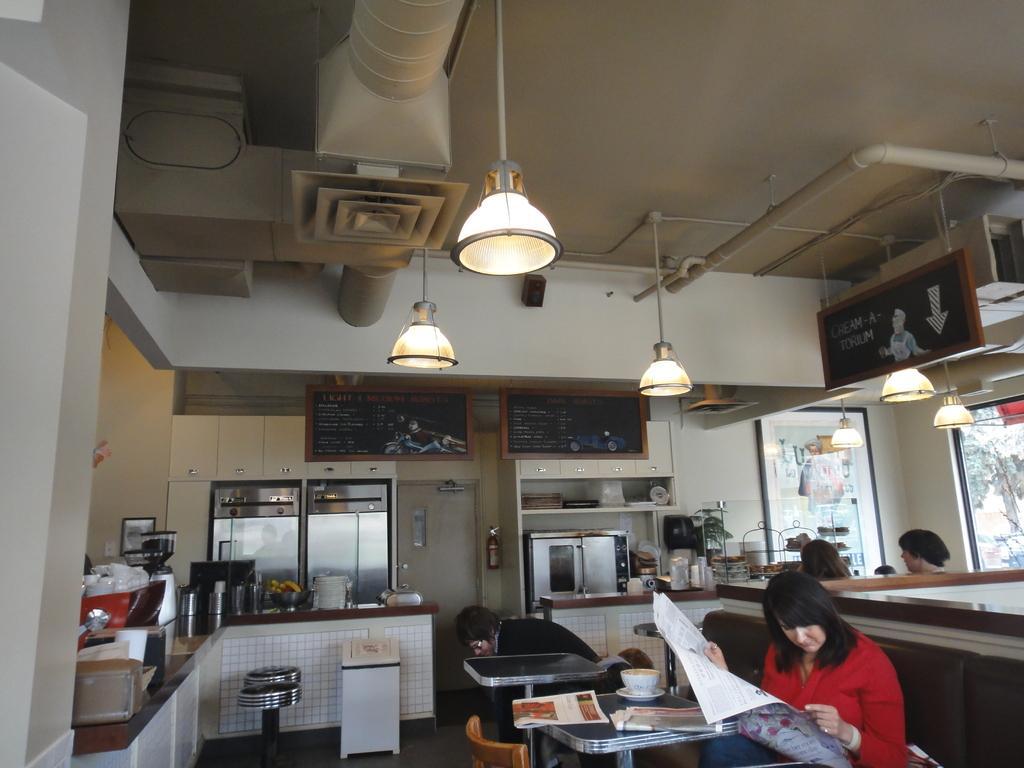Please provide a concise description of this image. in the image in the center we can see they were two persons. The lady she is sitting and she is reading news paper. And we can see the table chair. Coming to the back ground we can see kitchen materials and two persons were sitting. And we can see the wall and photo frames. 